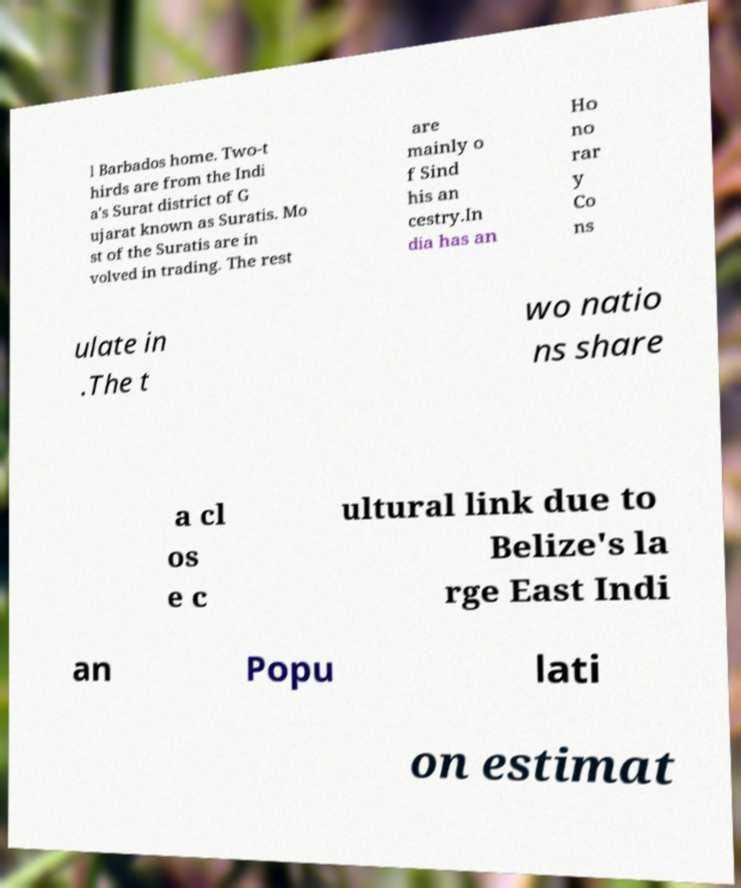Please identify and transcribe the text found in this image. l Barbados home. Two-t hirds are from the Indi a's Surat district of G ujarat known as Suratis. Mo st of the Suratis are in volved in trading. The rest are mainly o f Sind his an cestry.In dia has an Ho no rar y Co ns ulate in .The t wo natio ns share a cl os e c ultural link due to Belize's la rge East Indi an Popu lati on estimat 